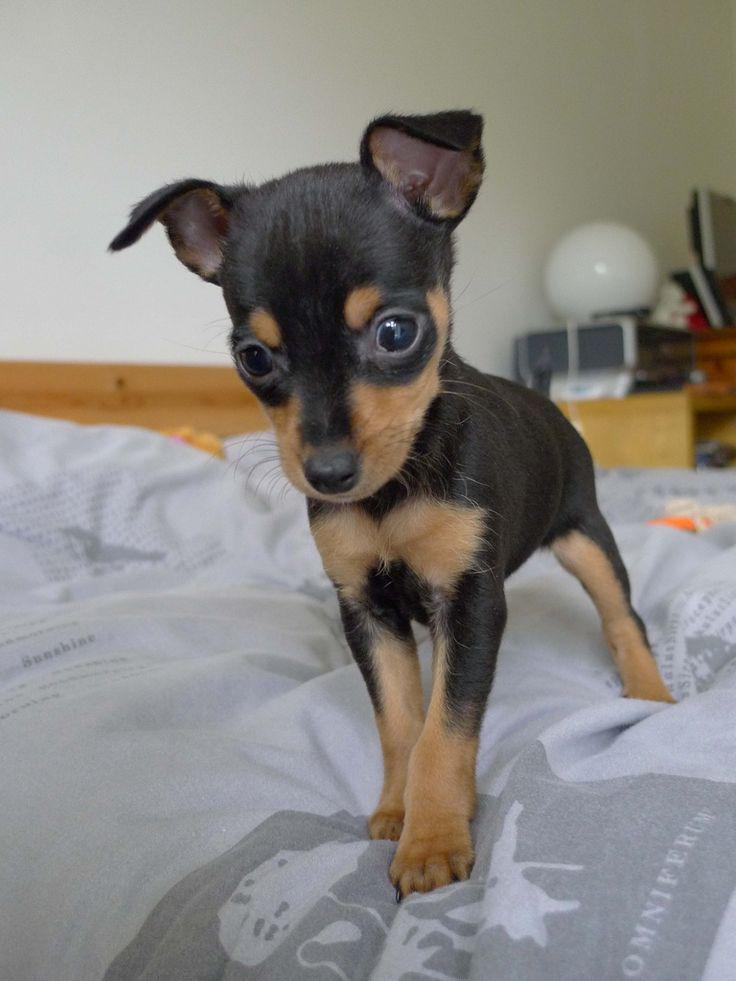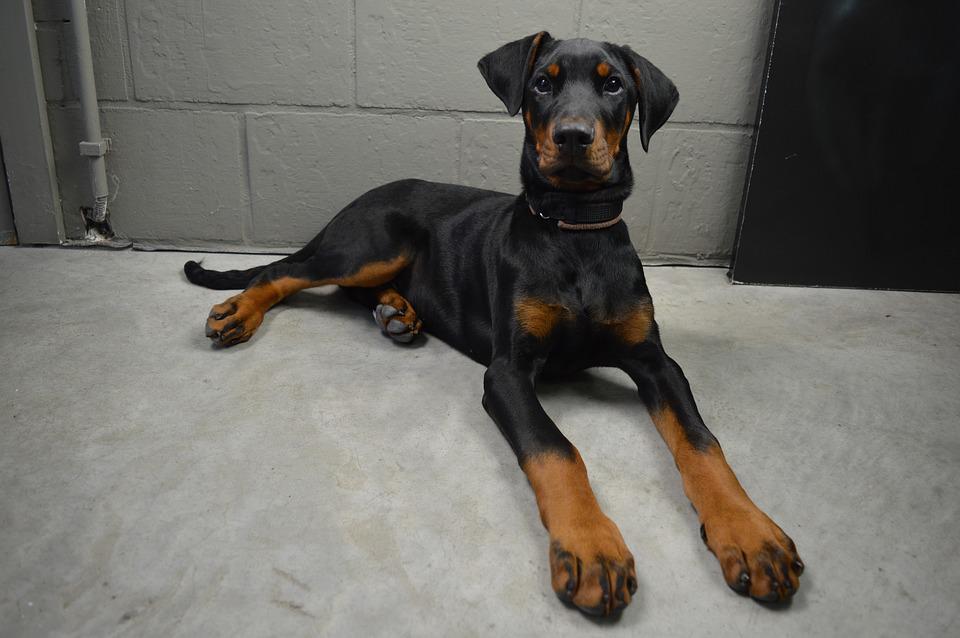The first image is the image on the left, the second image is the image on the right. Examine the images to the left and right. Is the description "There is a puppy biting a finger in one of the images." accurate? Answer yes or no. No. The first image is the image on the left, the second image is the image on the right. Examine the images to the left and right. Is the description "One image shows a human hand interacting with a juvenile dog." accurate? Answer yes or no. No. 